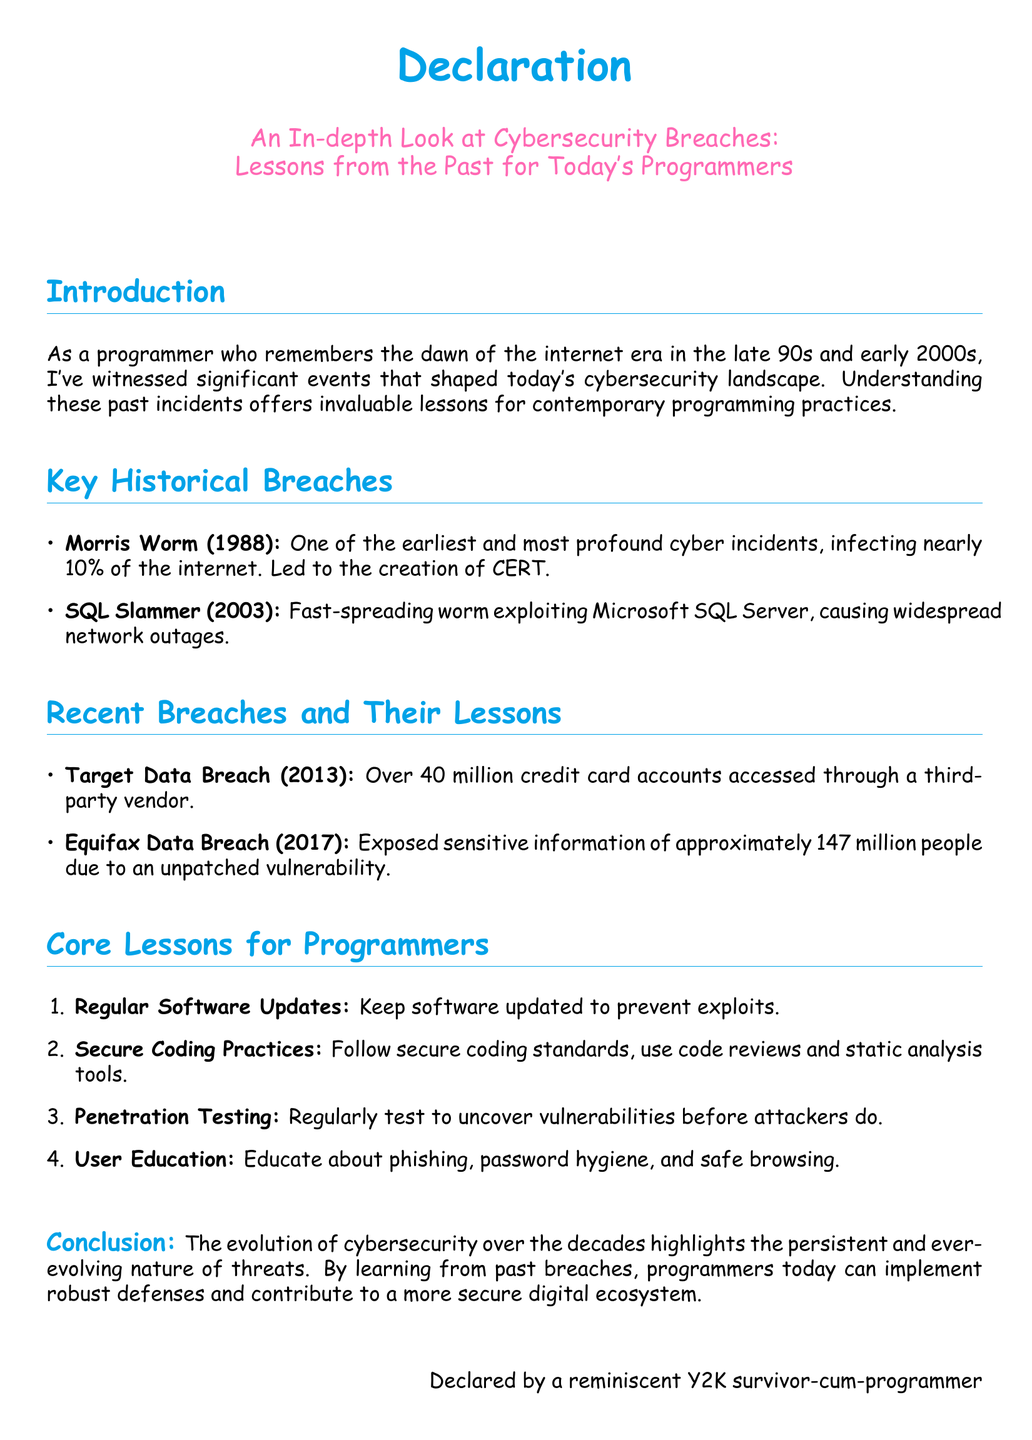What is the title of the document? The title is prominently displayed under the declaration section, highlighting the focus of the content.
Answer: An In-depth Look at Cybersecurity Breaches: Lessons from the Past for Today's Programmers What year did the Morris Worm occur? The document lists the Morris Worm as one of the key historical breaches with its occurrence year mentioned clearly.
Answer: 1988 How many credit card accounts were accessed in the Target Data Breach? The specific number of credit card accounts impacted by the Target Data Breach is mentioned in the recent breaches section.
Answer: Over 40 million What vulnerability led to the Equifax Data Breach? The document explains that the breach was due to an unpatched vulnerability, indicating a critical point.
Answer: Unpatched vulnerability What is one core lesson for programmers mentioned in the document? The document outlines several lessons for programmers, providing actionable takeaways.
Answer: Regular Software Updates What cybersecurity incident led to the creation of CERT? The Morris Worm incident is noted for its significant impact on the internet and related organizational responses.
Answer: Morris Worm What kind of testing is recommended to uncover vulnerabilities? The document clearly specifies a type of testing as a vital measure for programmers to prevent breaches.
Answer: Penetration Testing Who declared the document? The declaration at the end mentions the author's background, emphasizing their experience and perspective.
Answer: A reminiscent Y2K survivor-cum-programmer 